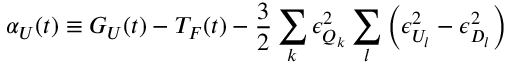Convert formula to latex. <formula><loc_0><loc_0><loc_500><loc_500>\alpha _ { U } ( t ) \equiv G _ { U } ( t ) - T _ { F } ( t ) - \frac { 3 } { 2 } \sum _ { k } \epsilon _ { Q _ { k } } ^ { 2 } \sum _ { l } \left ( \epsilon _ { U _ { l } } ^ { 2 } - \epsilon _ { D _ { l } } ^ { 2 } \right )</formula> 